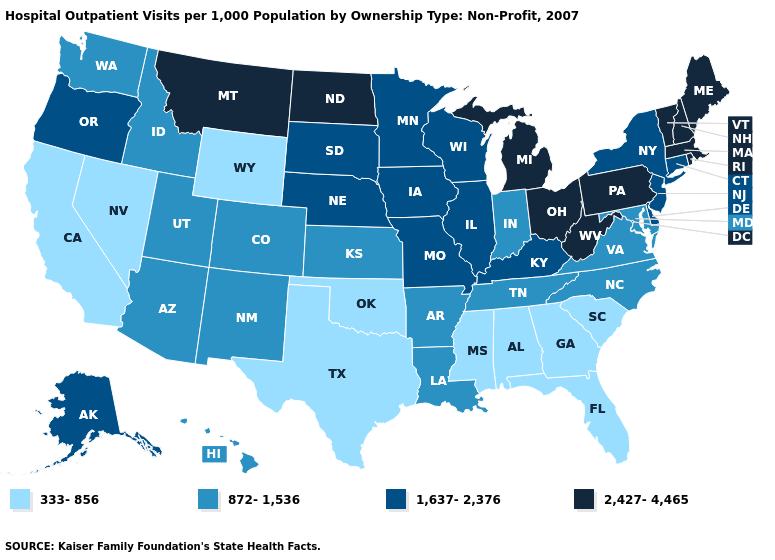Name the states that have a value in the range 2,427-4,465?
Be succinct. Maine, Massachusetts, Michigan, Montana, New Hampshire, North Dakota, Ohio, Pennsylvania, Rhode Island, Vermont, West Virginia. Which states have the lowest value in the USA?
Quick response, please. Alabama, California, Florida, Georgia, Mississippi, Nevada, Oklahoma, South Carolina, Texas, Wyoming. What is the highest value in states that border Florida?
Short answer required. 333-856. What is the value of Iowa?
Answer briefly. 1,637-2,376. Name the states that have a value in the range 872-1,536?
Write a very short answer. Arizona, Arkansas, Colorado, Hawaii, Idaho, Indiana, Kansas, Louisiana, Maryland, New Mexico, North Carolina, Tennessee, Utah, Virginia, Washington. Among the states that border Virginia , does Kentucky have the highest value?
Concise answer only. No. What is the highest value in the South ?
Write a very short answer. 2,427-4,465. What is the lowest value in states that border Iowa?
Give a very brief answer. 1,637-2,376. Does Maine have the same value as Rhode Island?
Give a very brief answer. Yes. What is the highest value in the USA?
Write a very short answer. 2,427-4,465. What is the highest value in the MidWest ?
Short answer required. 2,427-4,465. How many symbols are there in the legend?
Keep it brief. 4. Among the states that border North Carolina , which have the highest value?
Answer briefly. Tennessee, Virginia. Does the map have missing data?
Concise answer only. No. Among the states that border Massachusetts , which have the lowest value?
Short answer required. Connecticut, New York. 